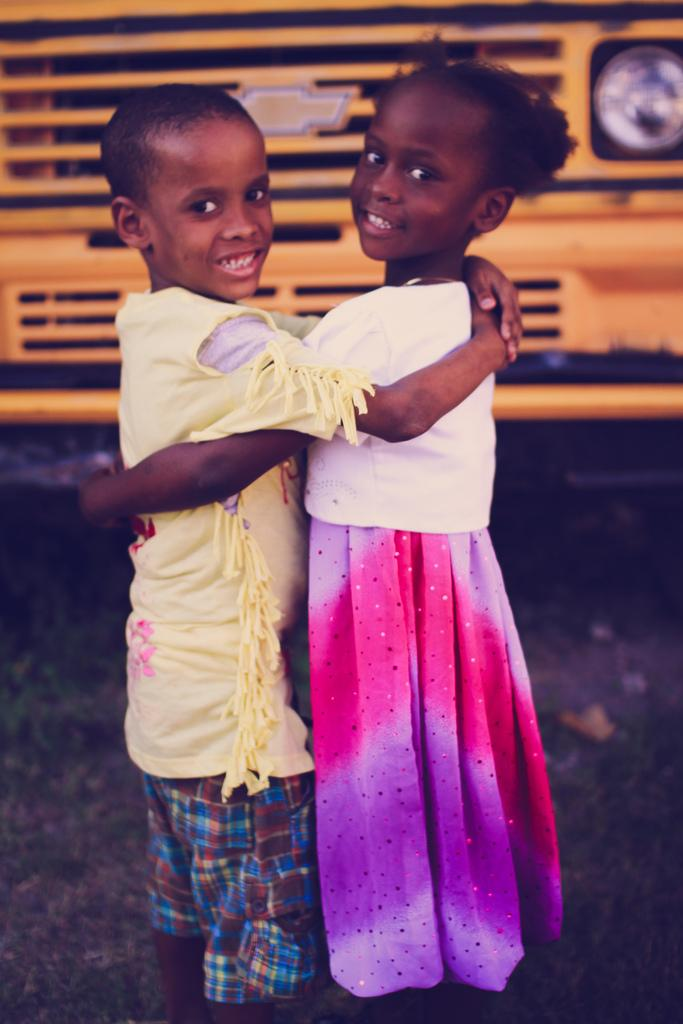How many kids are present in the image? There are two kids in the image. What is located at the bottom of the image? There is a road at the bottom of the image. What can be seen in the background of the image? There is a yellow bus in the background of the image. What type of pear is being used as a prop in the image? There is no pear present in the image. Where can the kids rest during their trip in the image? The image does not depict a trip, and there is no indication of a resting place for the kids. 